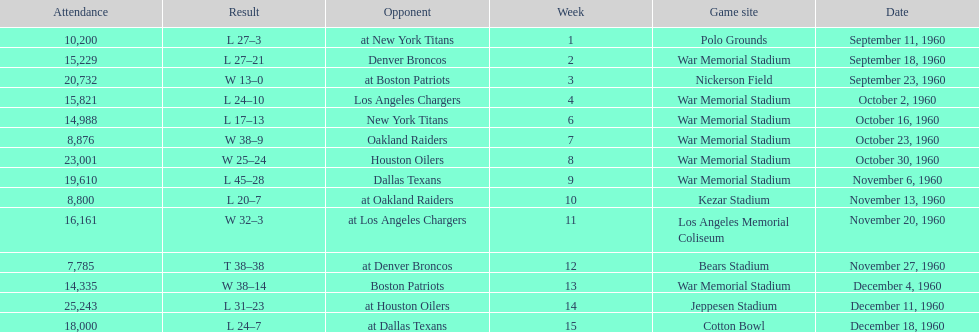What was the greatest point margin in a single game? 29. 